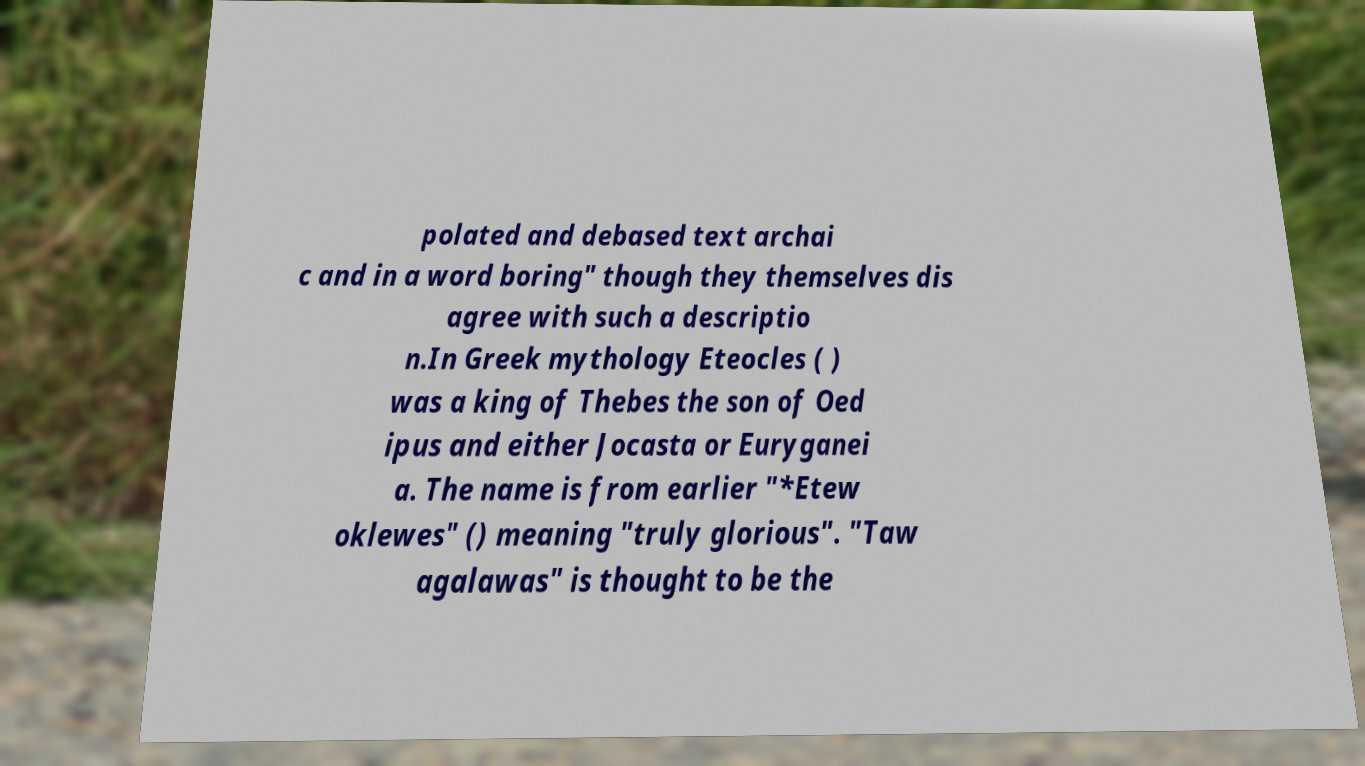Please identify and transcribe the text found in this image. polated and debased text archai c and in a word boring" though they themselves dis agree with such a descriptio n.In Greek mythology Eteocles ( ) was a king of Thebes the son of Oed ipus and either Jocasta or Euryganei a. The name is from earlier "*Etew oklewes" () meaning "truly glorious". "Taw agalawas" is thought to be the 